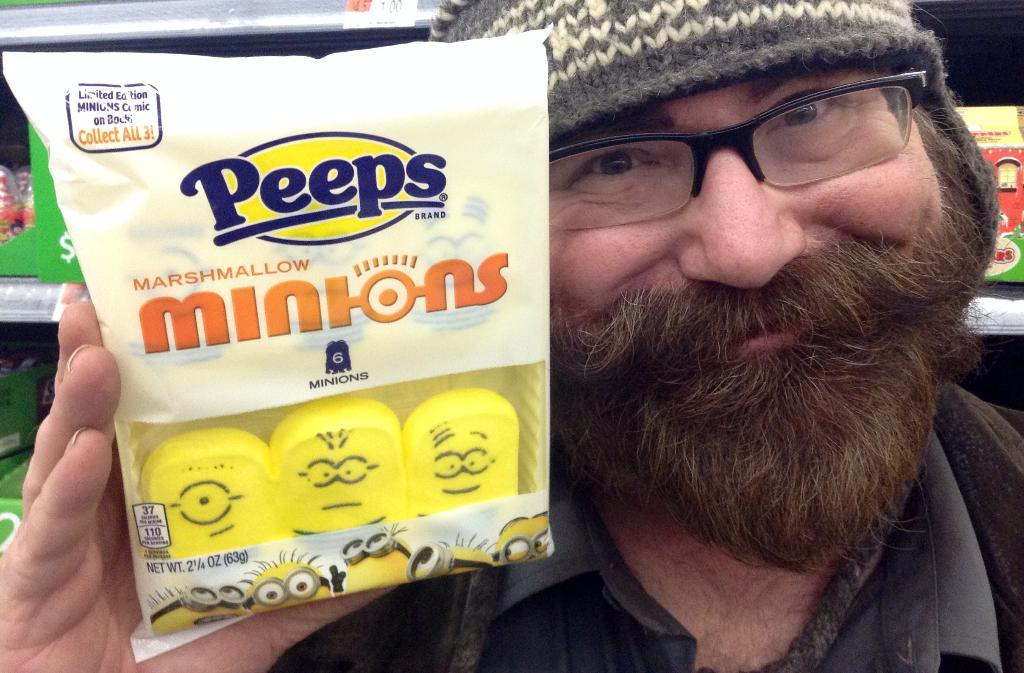What is the main subject of the image? There is a person in the image. What is the person wearing? The person is wearing a black dress, spectacles, and a cap. What is the person holding in the image? The person is holding a cover in his hands. Can you describe the colors of the cover? The cover is in yellow and white colors. What type of act is the person performing in the image? There is no indication of a performance or act in the image; it simply shows a person holding a cover. Is the person in the image at school? There is no information about the location or context of the image, so it cannot be determined if the person is at school. 